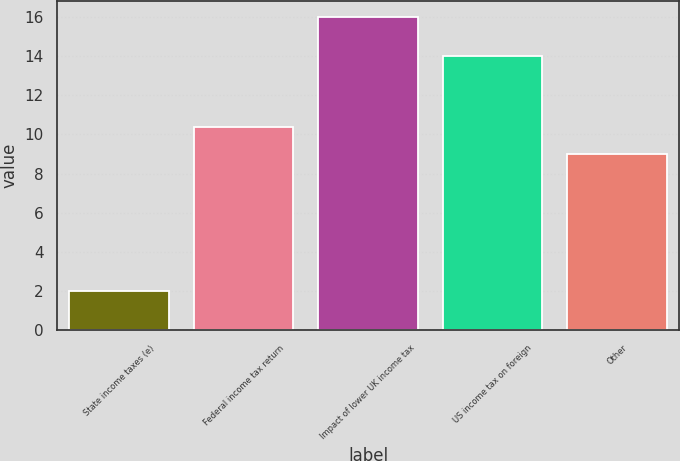Convert chart. <chart><loc_0><loc_0><loc_500><loc_500><bar_chart><fcel>State income taxes (e)<fcel>Federal income tax return<fcel>Impact of lower UK income tax<fcel>US income tax on foreign<fcel>Other<nl><fcel>2<fcel>10.4<fcel>16<fcel>14<fcel>9<nl></chart> 